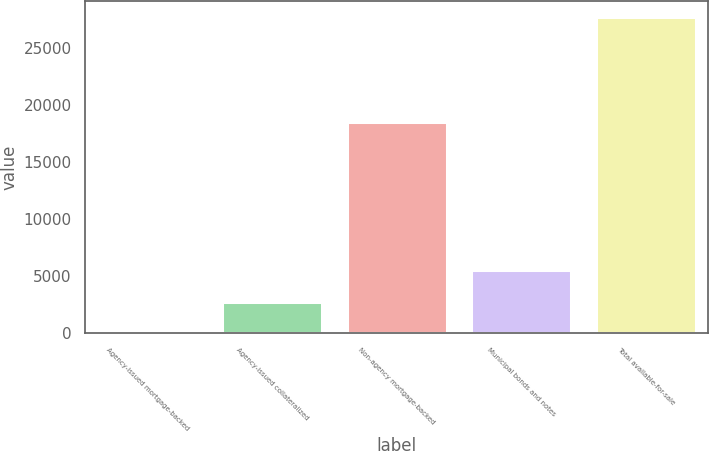Convert chart to OTSL. <chart><loc_0><loc_0><loc_500><loc_500><bar_chart><fcel>Agency-issued mortgage-backed<fcel>Agency-issued collateralized<fcel>Non-agency mortgage-backed<fcel>Municipal bonds and notes<fcel>Total available-for-sale<nl><fcel>4<fcel>2776.2<fcel>18486<fcel>5548.4<fcel>27726<nl></chart> 